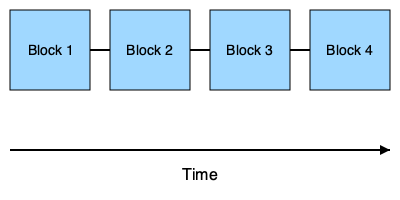In the context of secure patient data management, which shape in the diagram best represents the basic structure of a blockchain, and why is this structure beneficial for maintaining data integrity? 1. The diagram shows a series of connected rectangles, labeled as blocks.
2. Each block is connected to the next one, forming a chain-like structure.
3. This representation illustrates the fundamental structure of a blockchain:
   a. Each rectangle represents a block containing data (in this case, patient information).
   b. The connections between blocks represent the cryptographic links that ensure data integrity.
4. The arrow at the bottom indicates the progression of time, showing that blocks are added sequentially.
5. This structure is beneficial for maintaining data integrity because:
   a. Each block contains a reference to the previous block (cryptographic hash).
   b. Any attempt to alter data in a previous block would break the chain, making tampering evident.
   c. The sequential nature ensures a clear timeline of data entries.
6. In healthcare, this structure can help maintain an immutable and transparent record of patient data, ensuring that medical histories cannot be altered without detection.
Answer: Rectangle (Block); ensures data immutability and transparency 